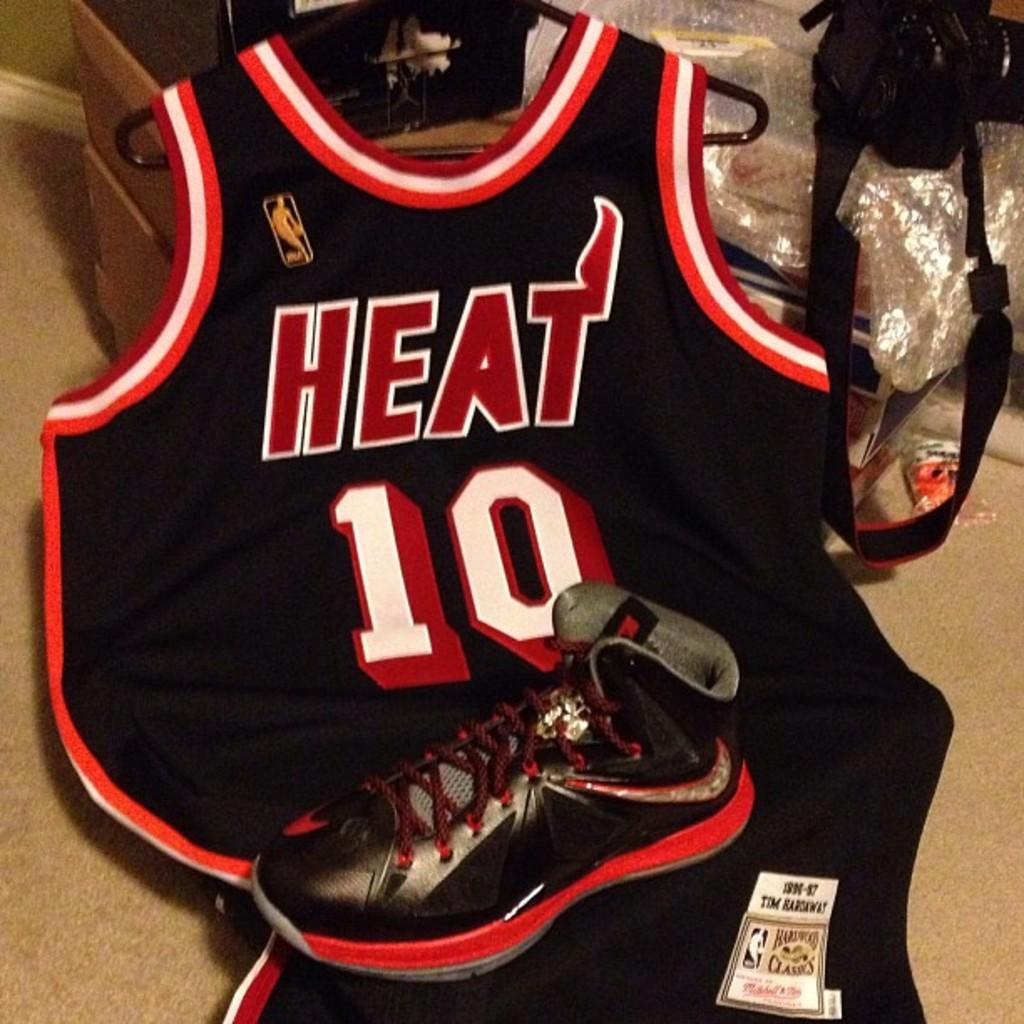<image>
Describe the image concisely. A trainer sits on a basketball top with Heat 10 on it. 